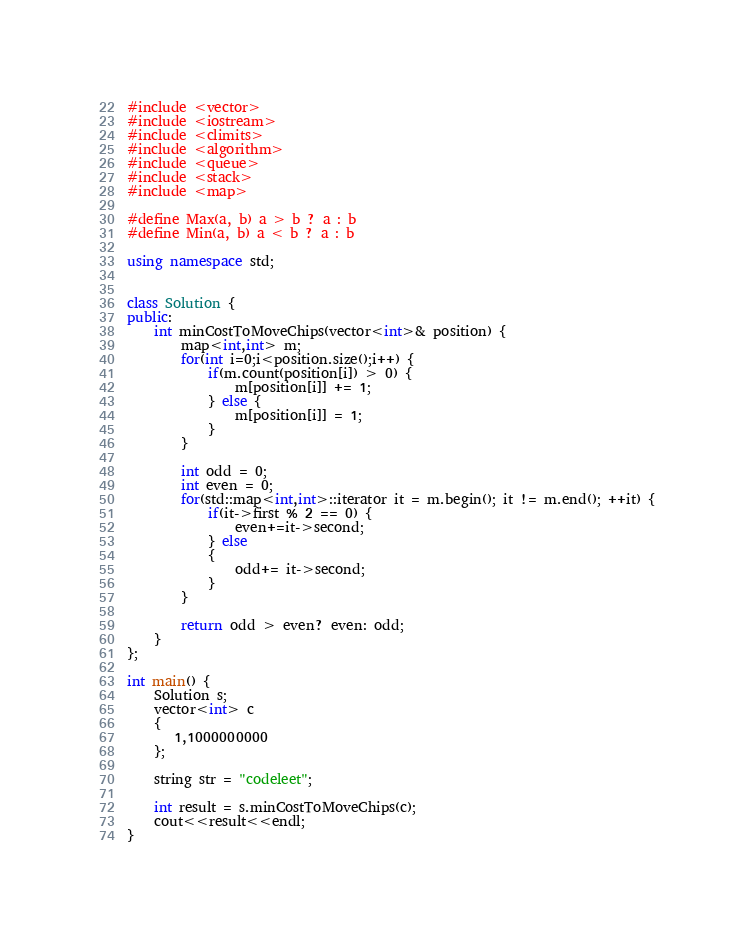Convert code to text. <code><loc_0><loc_0><loc_500><loc_500><_C++_>#include <vector>
#include <iostream>
#include <climits>
#include <algorithm>
#include <queue>
#include <stack>
#include <map>

#define Max(a, b) a > b ? a : b
#define Min(a, b) a < b ? a : b

using namespace std;


class Solution {
public:
    int minCostToMoveChips(vector<int>& position) {
        map<int,int> m;
        for(int i=0;i<position.size();i++) {
            if(m.count(position[i]) > 0) {
                m[position[i]] += 1;
            } else {
                m[position[i]] = 1;
            }
        }

        int odd = 0;
        int even = 0;
        for(std::map<int,int>::iterator it = m.begin(); it != m.end(); ++it) {
            if(it->first % 2 == 0) {
                even+=it->second;
            } else
            {
                odd+= it->second;
            }
        }

        return odd > even? even: odd;
    }
};

int main() {
    Solution s;
    vector<int> c
    {
       1,1000000000
    };

    string str = "codeleet";

    int result = s.minCostToMoveChips(c);
    cout<<result<<endl;
}</code> 